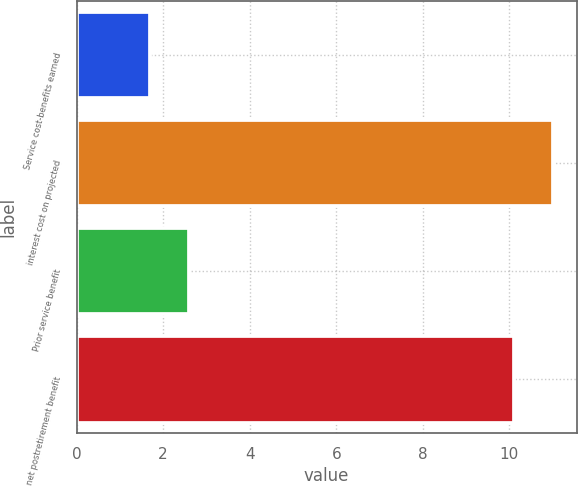Convert chart. <chart><loc_0><loc_0><loc_500><loc_500><bar_chart><fcel>Service cost-benefits earned<fcel>interest cost on projected<fcel>Prior service benefit<fcel>net postretirement benefit<nl><fcel>1.7<fcel>11<fcel>2.6<fcel>10.1<nl></chart> 